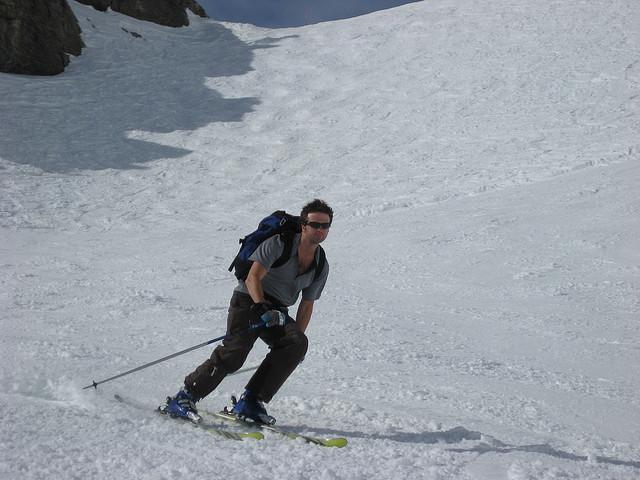What protective gear should the man wear?

Choices:
A) headband
B) scarf
C) helmet
D) knee pads helmet 